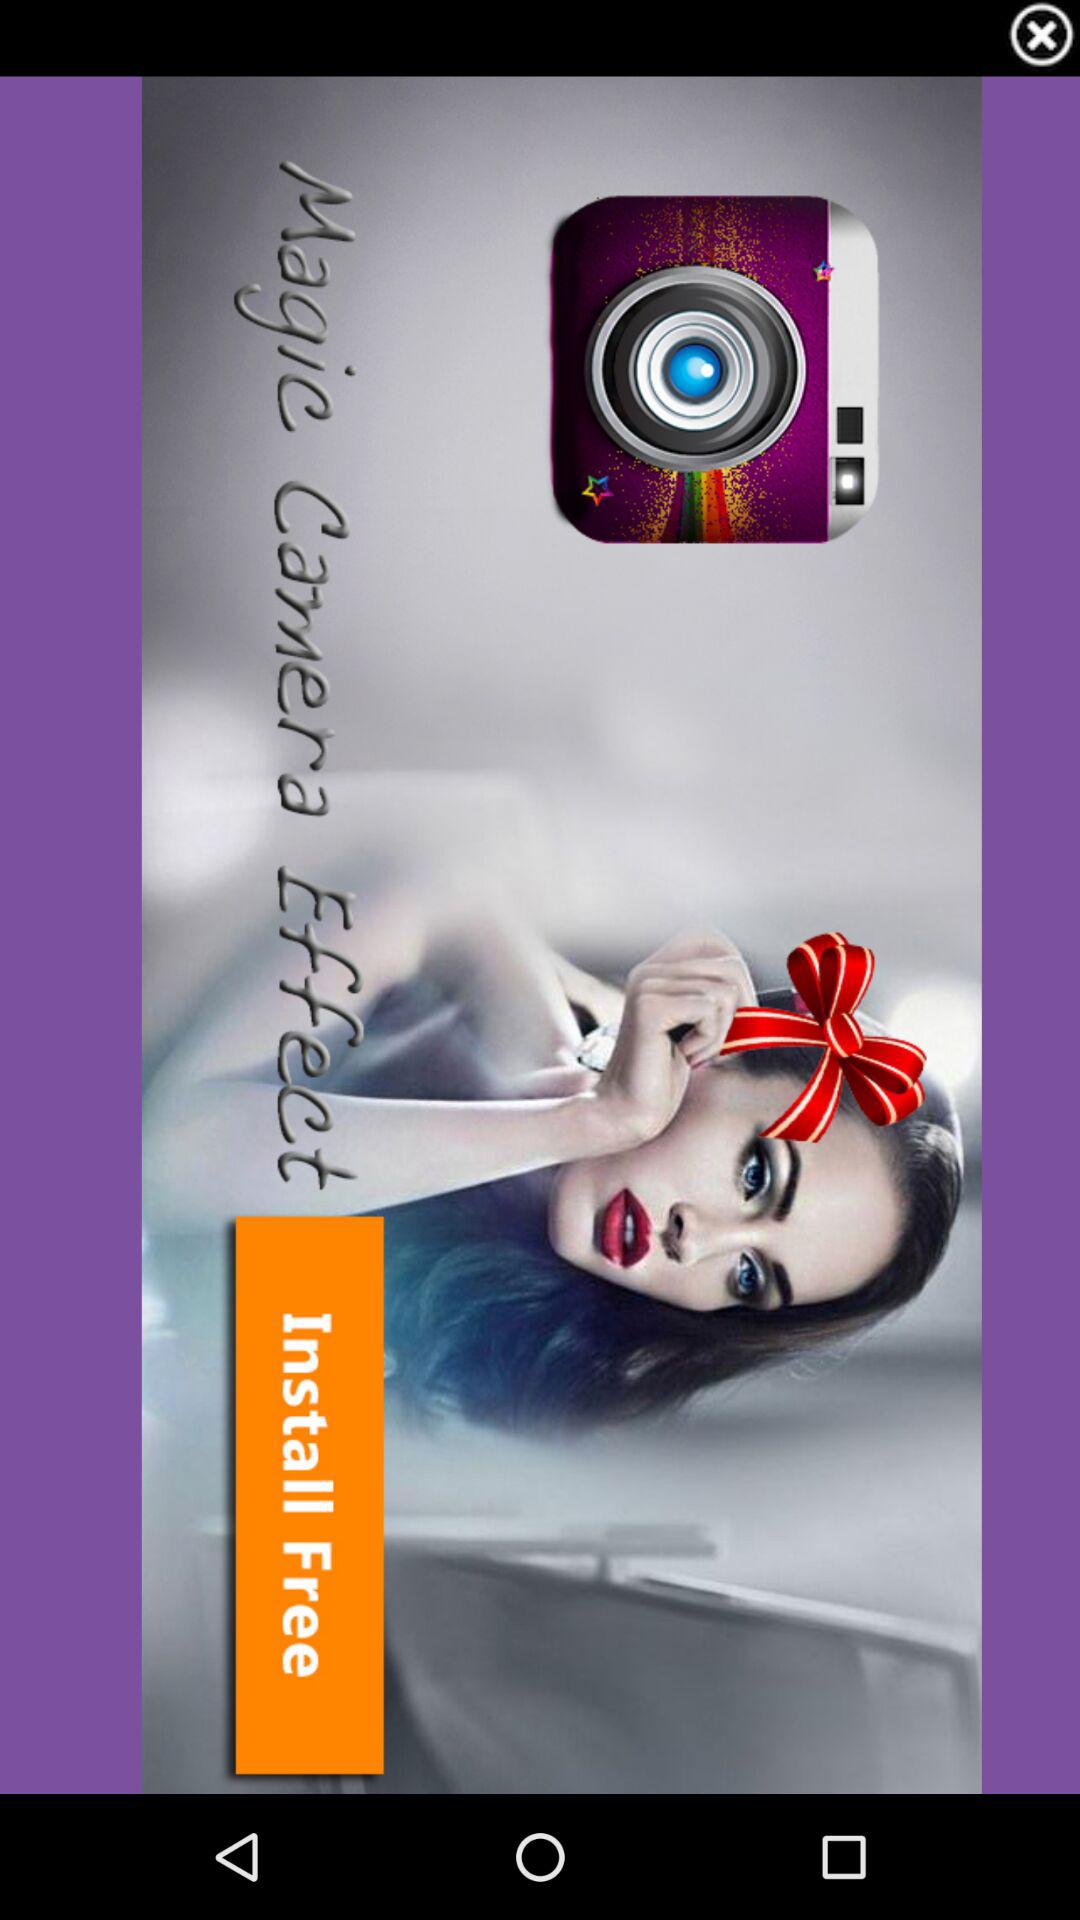What is the name of the application? The name of the application is "Magic Camera Effect". 